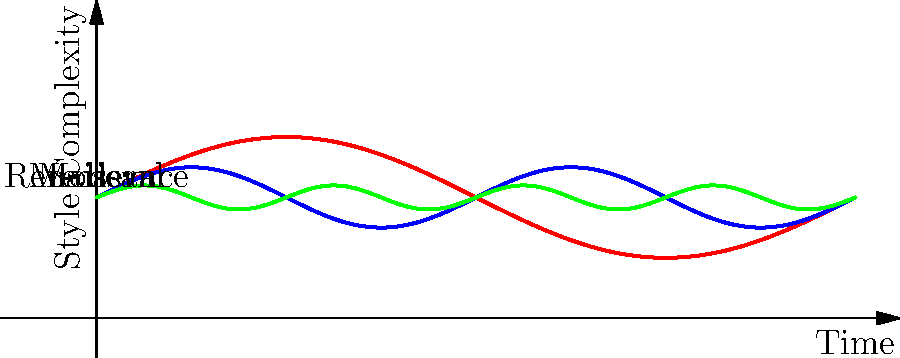Analyze the graph representing the evolution of handwriting styles throughout literary history. Which period shows the highest variability in style complexity, and how might this relate to the literary trends of that era? 1. Observe the three curves representing different literary periods:
   - Red curve: Medieval period
   - Blue curve: Renaissance period
   - Green curve: Modern period

2. Compare the amplitude of each curve:
   - Medieval (red) has the highest amplitude
   - Renaissance (blue) has a medium amplitude
   - Modern (green) has the lowest amplitude

3. Interpret the amplitude:
   - Higher amplitude indicates greater variability in style complexity
   - Lower amplitude suggests more consistency in style

4. Analyze the Medieval period (red curve):
   - Shows the highest peaks and lowest troughs
   - Indicates the most significant changes in style complexity

5. Consider the literary context of the Medieval period:
   - Transition from oral to written traditions
   - Development of various scripts (e.g., Uncial, Gothic)
   - Influence of religious and secular texts
   - Regional variations in writing styles

6. Relate to hand-lettering practices:
   - Medieval period offers the most diverse range of styles for inspiration
   - Provides opportunities for creating dramatic contrasts in hand-lettered quotes

7. Conclusion:
   The Medieval period shows the highest variability in style complexity, likely due to the diverse influences and developmental stages of writing during this era.
Answer: Medieval period; diverse influences and developmental stages of writing. 